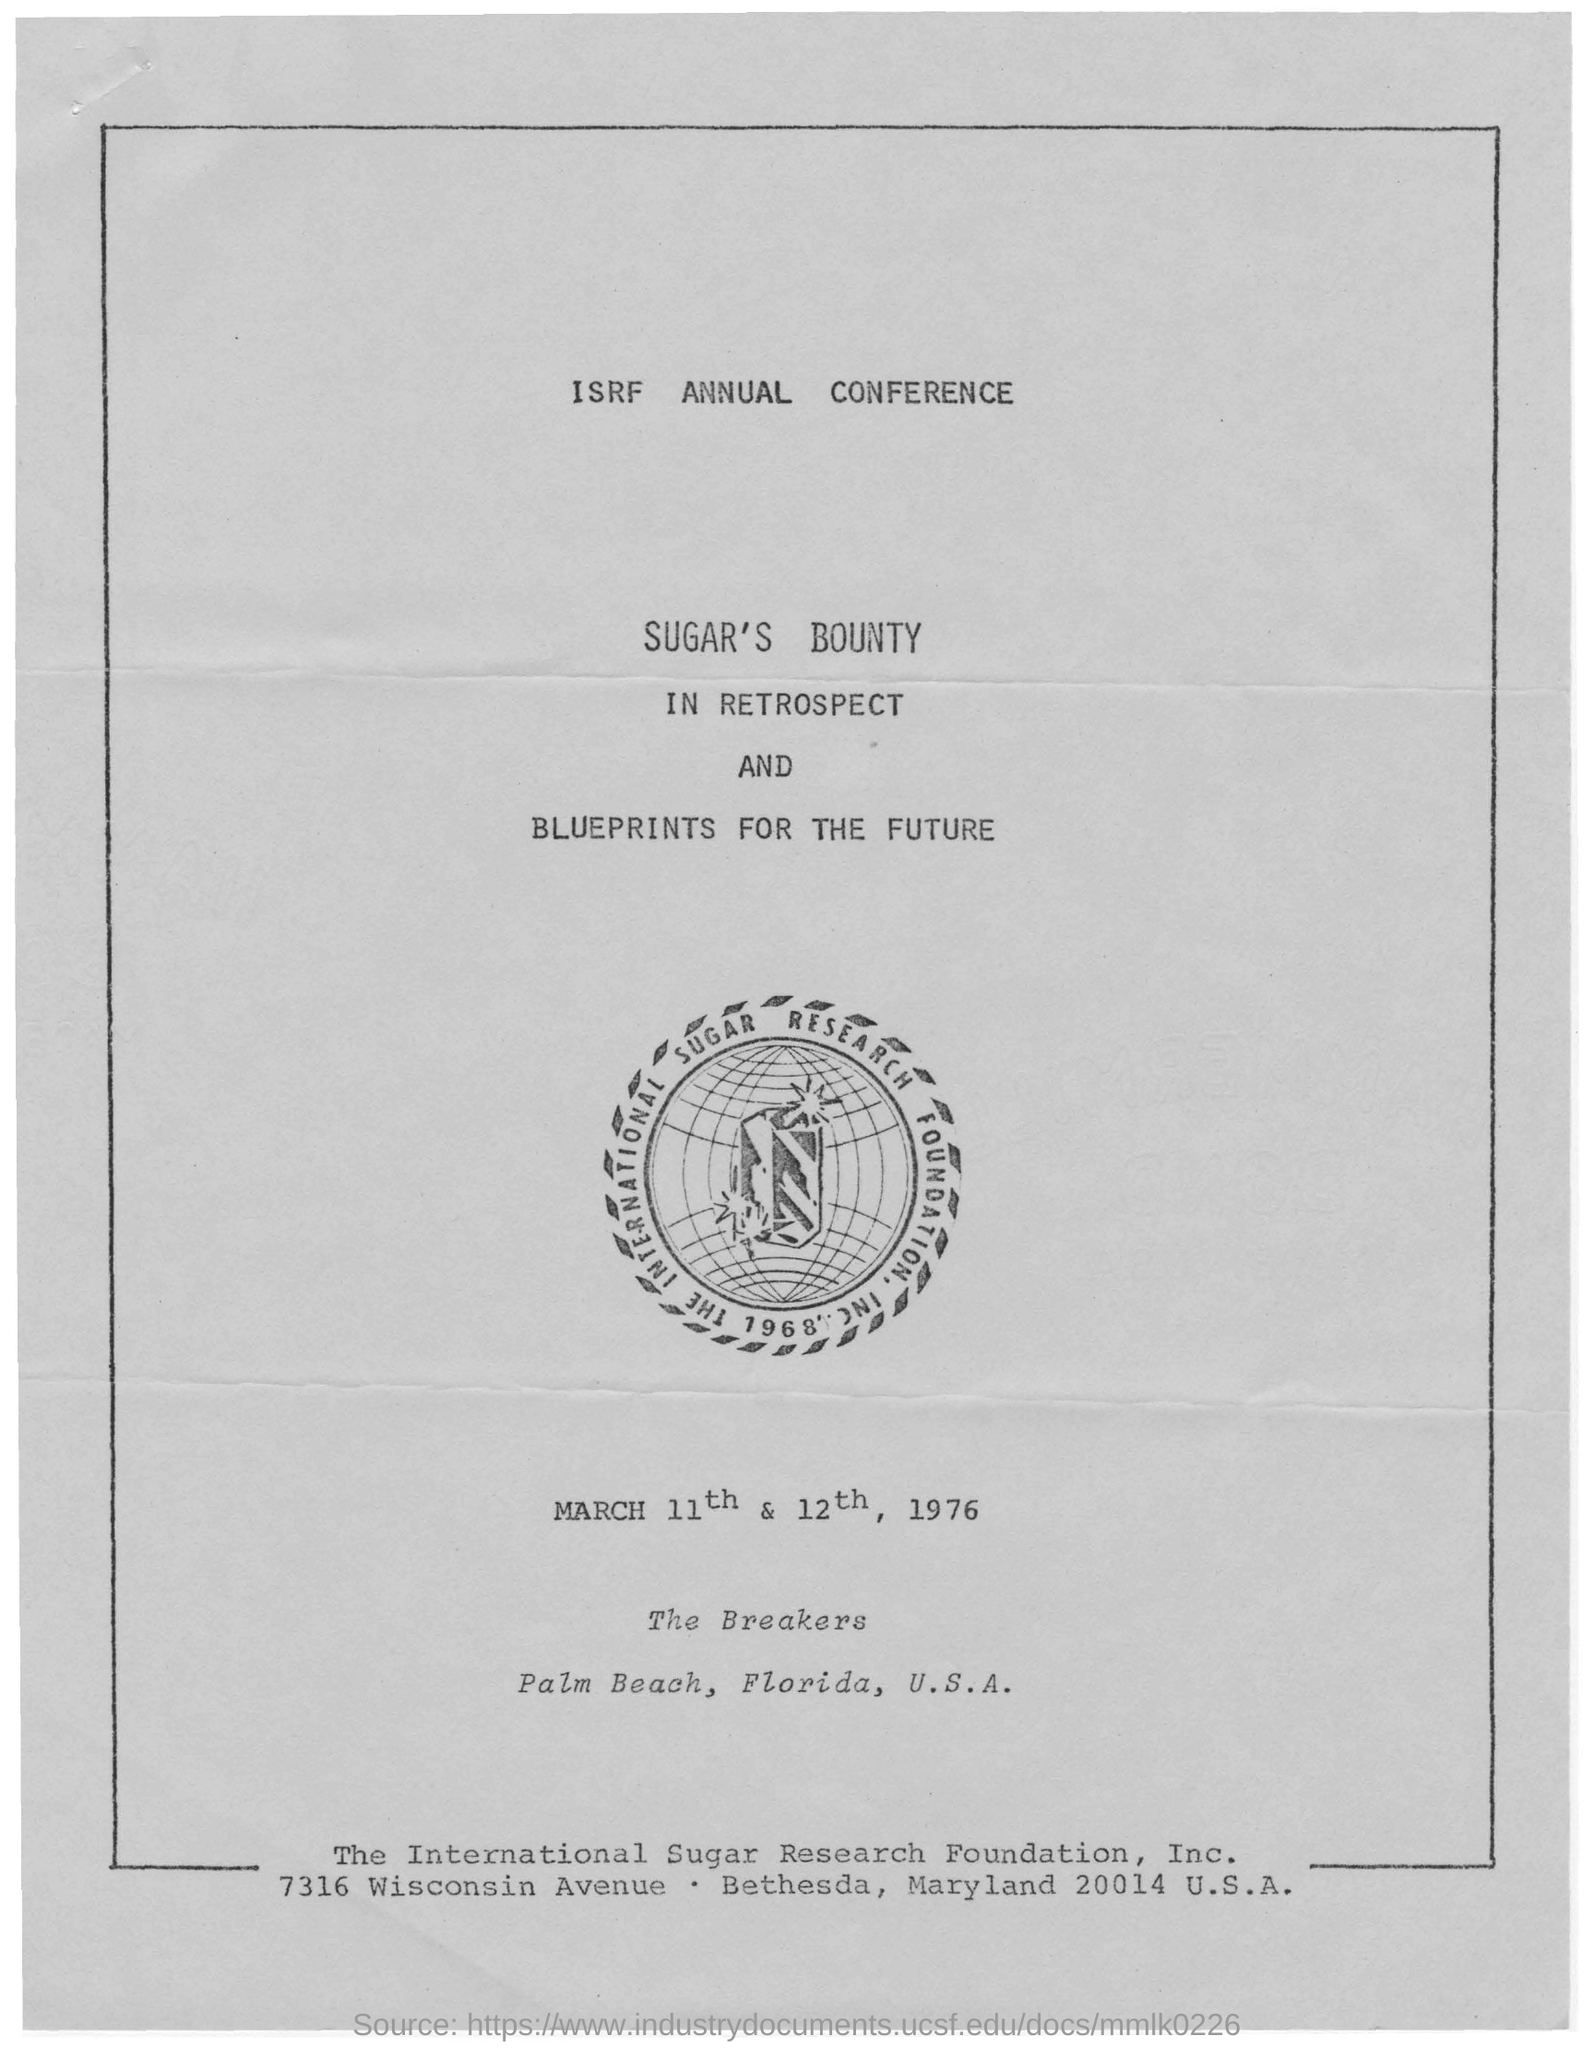Draw attention to some important aspects in this diagram. The annual conference is held on March 11th and 12th of 1976. The International Sugar Research Foundation, Inc. is the name of the foundation given. The name of the conference is the ISRF Annual Conference. This annual conference is held on the topic of sugar's bounty in retrospect and blueprints for the future. 